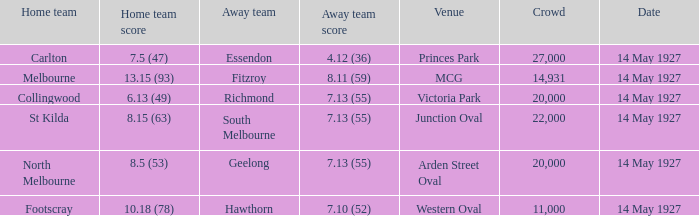How much is the sum of every crowd in attendance when the away score was 7.13 (55) for Richmond? 20000.0. Can you parse all the data within this table? {'header': ['Home team', 'Home team score', 'Away team', 'Away team score', 'Venue', 'Crowd', 'Date'], 'rows': [['Carlton', '7.5 (47)', 'Essendon', '4.12 (36)', 'Princes Park', '27,000', '14 May 1927'], ['Melbourne', '13.15 (93)', 'Fitzroy', '8.11 (59)', 'MCG', '14,931', '14 May 1927'], ['Collingwood', '6.13 (49)', 'Richmond', '7.13 (55)', 'Victoria Park', '20,000', '14 May 1927'], ['St Kilda', '8.15 (63)', 'South Melbourne', '7.13 (55)', 'Junction Oval', '22,000', '14 May 1927'], ['North Melbourne', '8.5 (53)', 'Geelong', '7.13 (55)', 'Arden Street Oval', '20,000', '14 May 1927'], ['Footscray', '10.18 (78)', 'Hawthorn', '7.10 (52)', 'Western Oval', '11,000', '14 May 1927']]} 